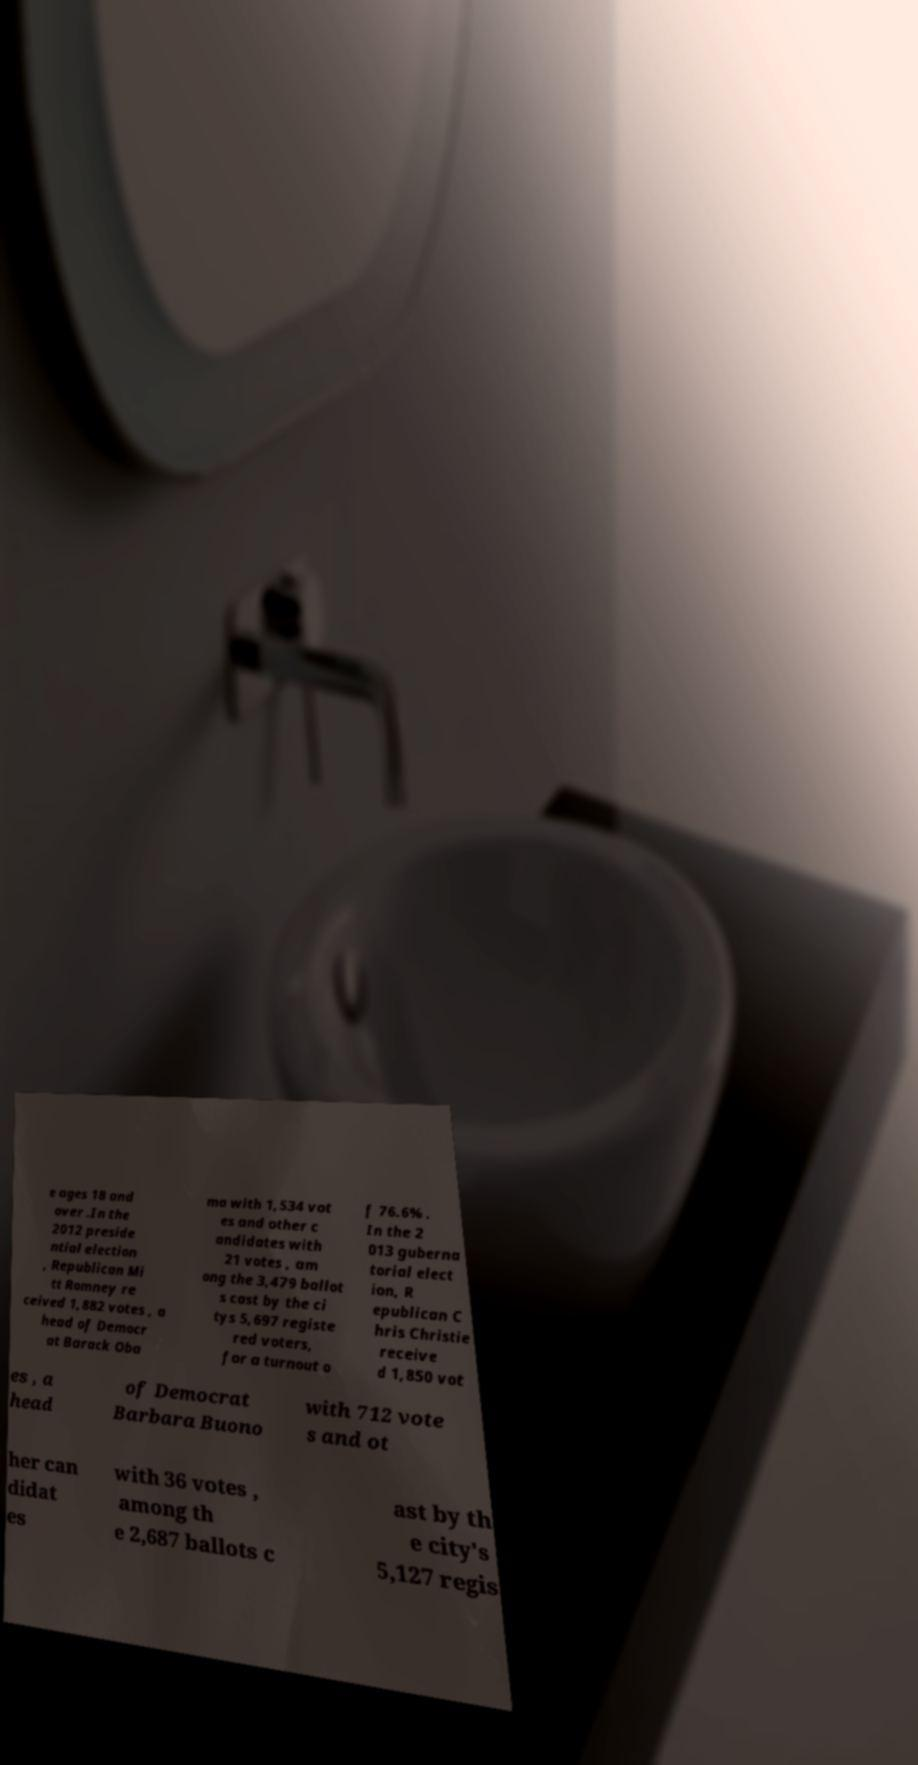Could you assist in decoding the text presented in this image and type it out clearly? e ages 18 and over .In the 2012 preside ntial election , Republican Mi tt Romney re ceived 1,882 votes , a head of Democr at Barack Oba ma with 1,534 vot es and other c andidates with 21 votes , am ong the 3,479 ballot s cast by the ci tys 5,697 registe red voters, for a turnout o f 76.6% . In the 2 013 guberna torial elect ion, R epublican C hris Christie receive d 1,850 vot es , a head of Democrat Barbara Buono with 712 vote s and ot her can didat es with 36 votes , among th e 2,687 ballots c ast by th e city's 5,127 regis 